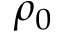<formula> <loc_0><loc_0><loc_500><loc_500>\rho _ { 0 }</formula> 